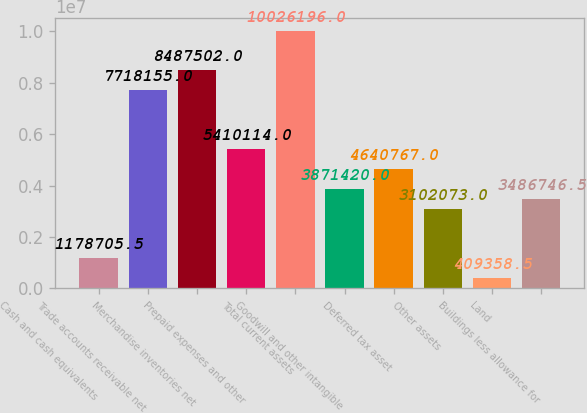Convert chart to OTSL. <chart><loc_0><loc_0><loc_500><loc_500><bar_chart><fcel>Cash and cash equivalents<fcel>Trade accounts receivable net<fcel>Merchandise inventories net<fcel>Prepaid expenses and other<fcel>Total current assets<fcel>Goodwill and other intangible<fcel>Deferred tax asset<fcel>Other assets<fcel>Land<fcel>Buildings less allowance for<nl><fcel>1.17871e+06<fcel>7.71816e+06<fcel>8.4875e+06<fcel>5.41011e+06<fcel>1.00262e+07<fcel>3.87142e+06<fcel>4.64077e+06<fcel>3.10207e+06<fcel>409358<fcel>3.48675e+06<nl></chart> 